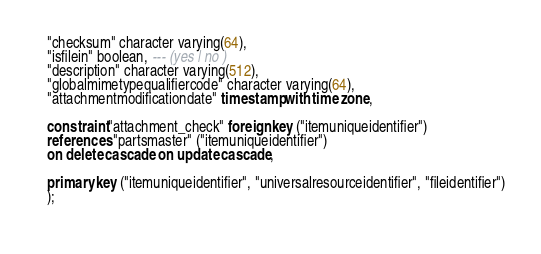Convert code to text. <code><loc_0><loc_0><loc_500><loc_500><_SQL_>   "checksum" character varying(64),
   "isfilein" boolean, --- (yes | no )
   "description" character varying(512),
   "globalmimetypequalifiercode" character varying(64),
   "attachmentmodificationdate" timestamp with time zone,
   
   constraint "attachment_check" foreign key ("itemuniqueidentifier") 
   references "partsmaster" ("itemuniqueidentifier") 
   on delete cascade on update cascade,
   
   primary key ("itemuniqueidentifier", "universalresourceidentifier", "fileidentifier")
   );
   
</code> 